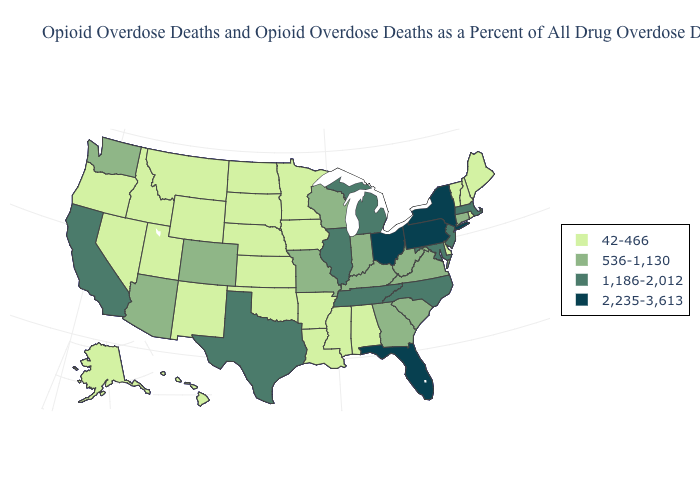Does Maine have a higher value than Delaware?
Quick response, please. No. Name the states that have a value in the range 536-1,130?
Write a very short answer. Arizona, Colorado, Connecticut, Georgia, Indiana, Kentucky, Missouri, South Carolina, Virginia, Washington, West Virginia, Wisconsin. Does Illinois have a higher value than North Carolina?
Answer briefly. No. Name the states that have a value in the range 536-1,130?
Keep it brief. Arizona, Colorado, Connecticut, Georgia, Indiana, Kentucky, Missouri, South Carolina, Virginia, Washington, West Virginia, Wisconsin. Name the states that have a value in the range 42-466?
Answer briefly. Alabama, Alaska, Arkansas, Delaware, Hawaii, Idaho, Iowa, Kansas, Louisiana, Maine, Minnesota, Mississippi, Montana, Nebraska, Nevada, New Hampshire, New Mexico, North Dakota, Oklahoma, Oregon, Rhode Island, South Dakota, Utah, Vermont, Wyoming. What is the value of Arizona?
Write a very short answer. 536-1,130. What is the value of South Dakota?
Be succinct. 42-466. What is the value of North Carolina?
Answer briefly. 1,186-2,012. What is the value of New Jersey?
Be succinct. 1,186-2,012. Does the map have missing data?
Concise answer only. No. Does Alaska have the same value as Vermont?
Concise answer only. Yes. Does Oklahoma have the lowest value in the USA?
Short answer required. Yes. Among the states that border North Carolina , which have the lowest value?
Short answer required. Georgia, South Carolina, Virginia. Does New York have the highest value in the Northeast?
Short answer required. Yes. Which states have the lowest value in the Northeast?
Write a very short answer. Maine, New Hampshire, Rhode Island, Vermont. 